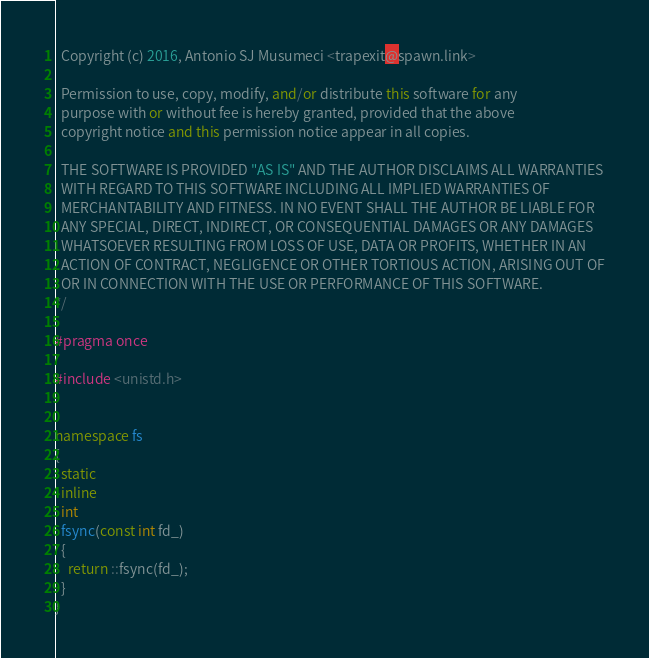<code> <loc_0><loc_0><loc_500><loc_500><_C++_>
  Copyright (c) 2016, Antonio SJ Musumeci <trapexit@spawn.link>

  Permission to use, copy, modify, and/or distribute this software for any
  purpose with or without fee is hereby granted, provided that the above
  copyright notice and this permission notice appear in all copies.

  THE SOFTWARE IS PROVIDED "AS IS" AND THE AUTHOR DISCLAIMS ALL WARRANTIES
  WITH REGARD TO THIS SOFTWARE INCLUDING ALL IMPLIED WARRANTIES OF
  MERCHANTABILITY AND FITNESS. IN NO EVENT SHALL THE AUTHOR BE LIABLE FOR
  ANY SPECIAL, DIRECT, INDIRECT, OR CONSEQUENTIAL DAMAGES OR ANY DAMAGES
  WHATSOEVER RESULTING FROM LOSS OF USE, DATA OR PROFITS, WHETHER IN AN
  ACTION OF CONTRACT, NEGLIGENCE OR OTHER TORTIOUS ACTION, ARISING OUT OF
  OR IN CONNECTION WITH THE USE OR PERFORMANCE OF THIS SOFTWARE.
*/

#pragma once

#include <unistd.h>


namespace fs
{
  static
  inline
  int
  fsync(const int fd_)
  {
    return ::fsync(fd_);
  }
}
</code> 